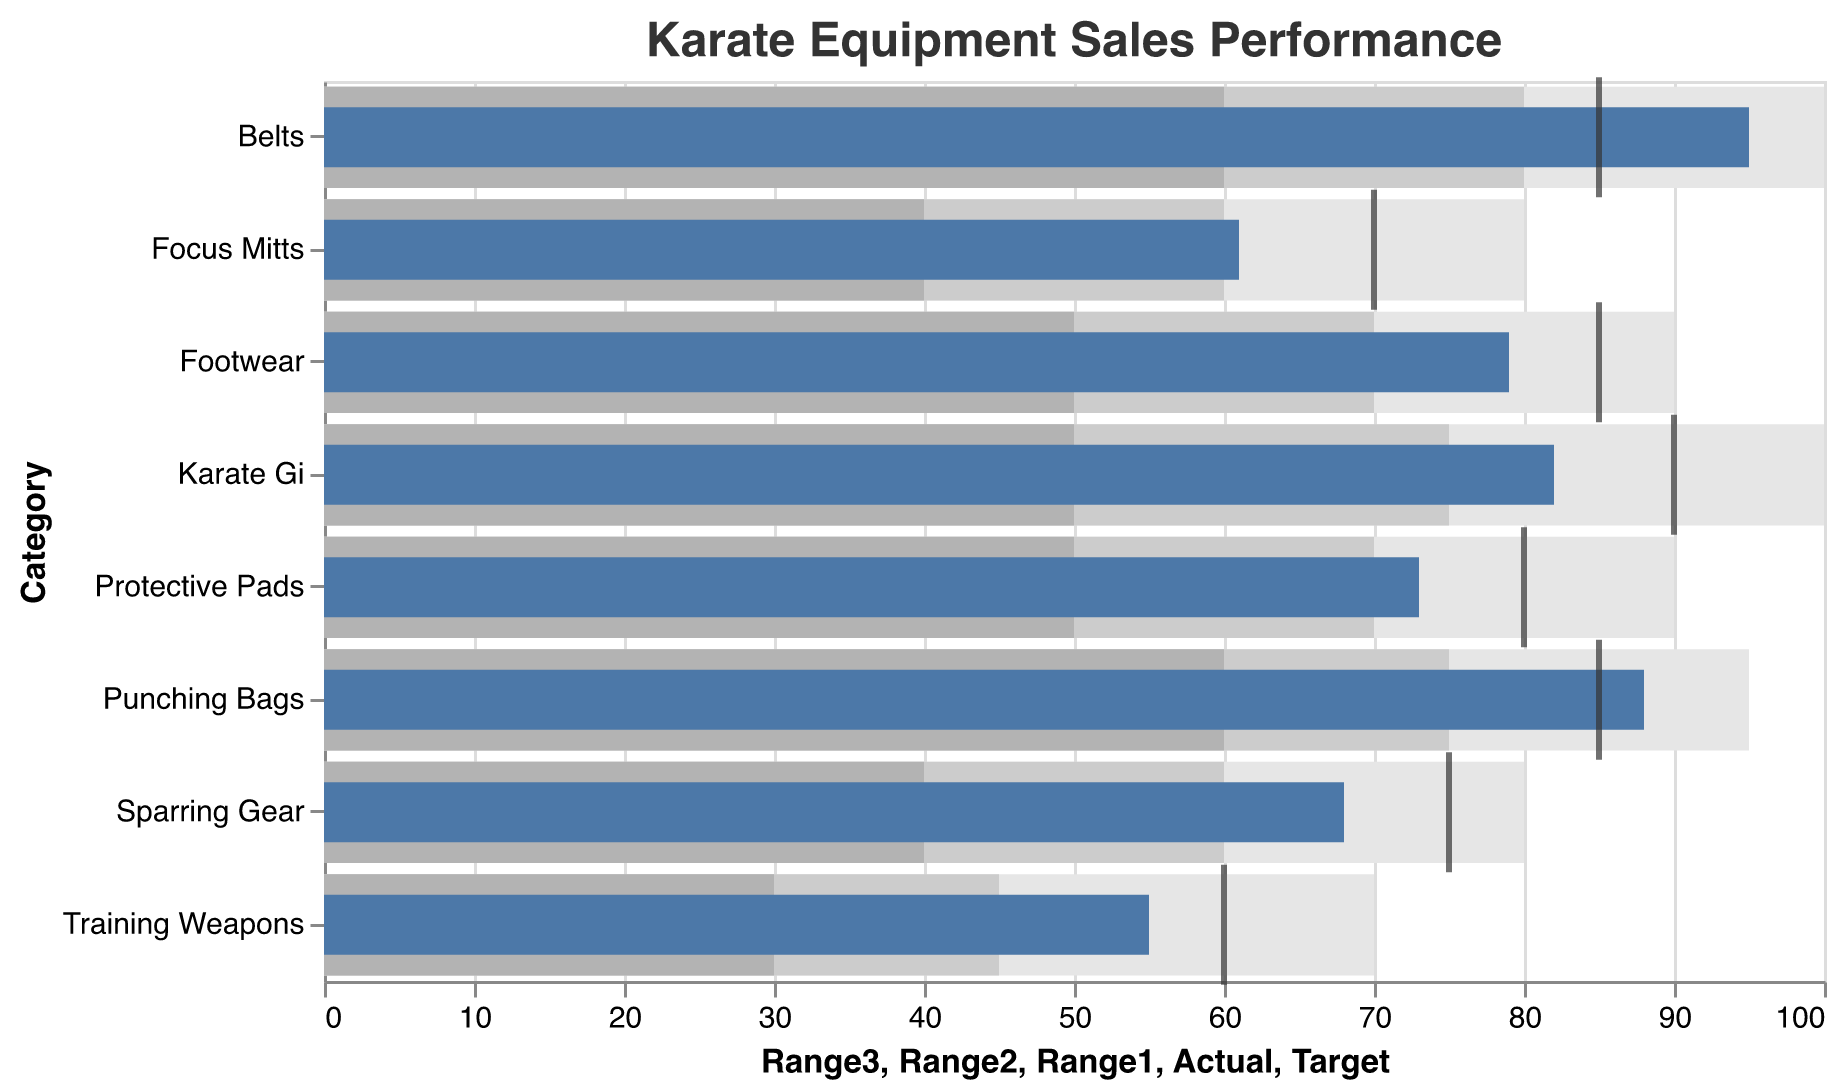What is the title of the chart? The title is located at the top of the chart and reads: "Karate Equipment Sales Performance"
Answer: Karate Equipment Sales Performance How many product categories are displayed in the chart? The chart has a distinct bar for each category, totaling eight categories
Answer: 8 Which product category exceeded its target by the largest margin? By observing the positions of the bars and target ticks, it's evident that belts exceeded their target by 10 units (95 actual vs. 85 target)
Answer: Belts What are the actual and target sales values for Punching Bags? The small blue bar for Punching Bags indicates actual sales at 88, and the black tick mark represents the target at 85
Answer: Actual: 88, Target: 85 Which product category had actual sales closest to its target? The bars and ticks reveal that Training Weapons had actual sales of 55 and a target of 60, giving the smallest relative difference of 5 units
Answer: Training Weapons What is the average of the actual sales values across all categories? Summing the actual sales values (82 + 68 + 55 + 95 + 73 + 61 + 88 + 79) equals 601. Dividing by the 8 categories results in an average of 75.125
Answer: 75.125 How many product categories met or exceeded their target sales? Checking the bars relative to target ticks shows that 4 categories (Belts, Punching Bags, Karate Gi, and Footwear) met or exceeded their targets
Answer: 4 In which color are the actual sales values represented? The bars representing actual sales are colored in a distinct shade of blue
Answer: Blue Which product category has the highest actual sales, and what is the value? The longest blue bar indicates that Belts have the highest actual sales value at 95
Answer: Belts, 95 How do the actual sales of Sparring Gear compare to its target sales? The blue bar for Sparring Gear is at 68 and the target tick is at 75, so actual sales are 7 units below the target
Answer: 7 units below 